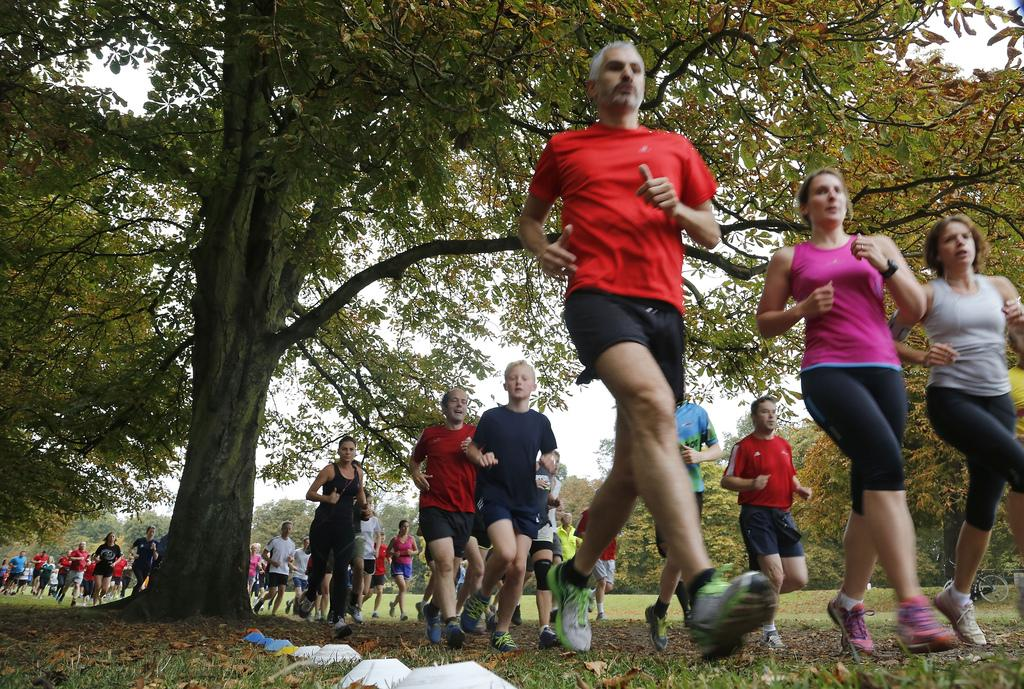What is the man in the image doing? The man is running in the image. What color is the man's t-shirt? The man is wearing a red t-shirt. How many girls are running in the image? There are two girls running in the image. Where are the girls located in the image? The girls are on the right side of the image. What can be seen on the left side of the image? There is a tree on the left side of the image. What type of owl can be seen perched on the tree in the image? There is no owl present in the image; it only features a man and two girls running, as well as a tree on the left side. 